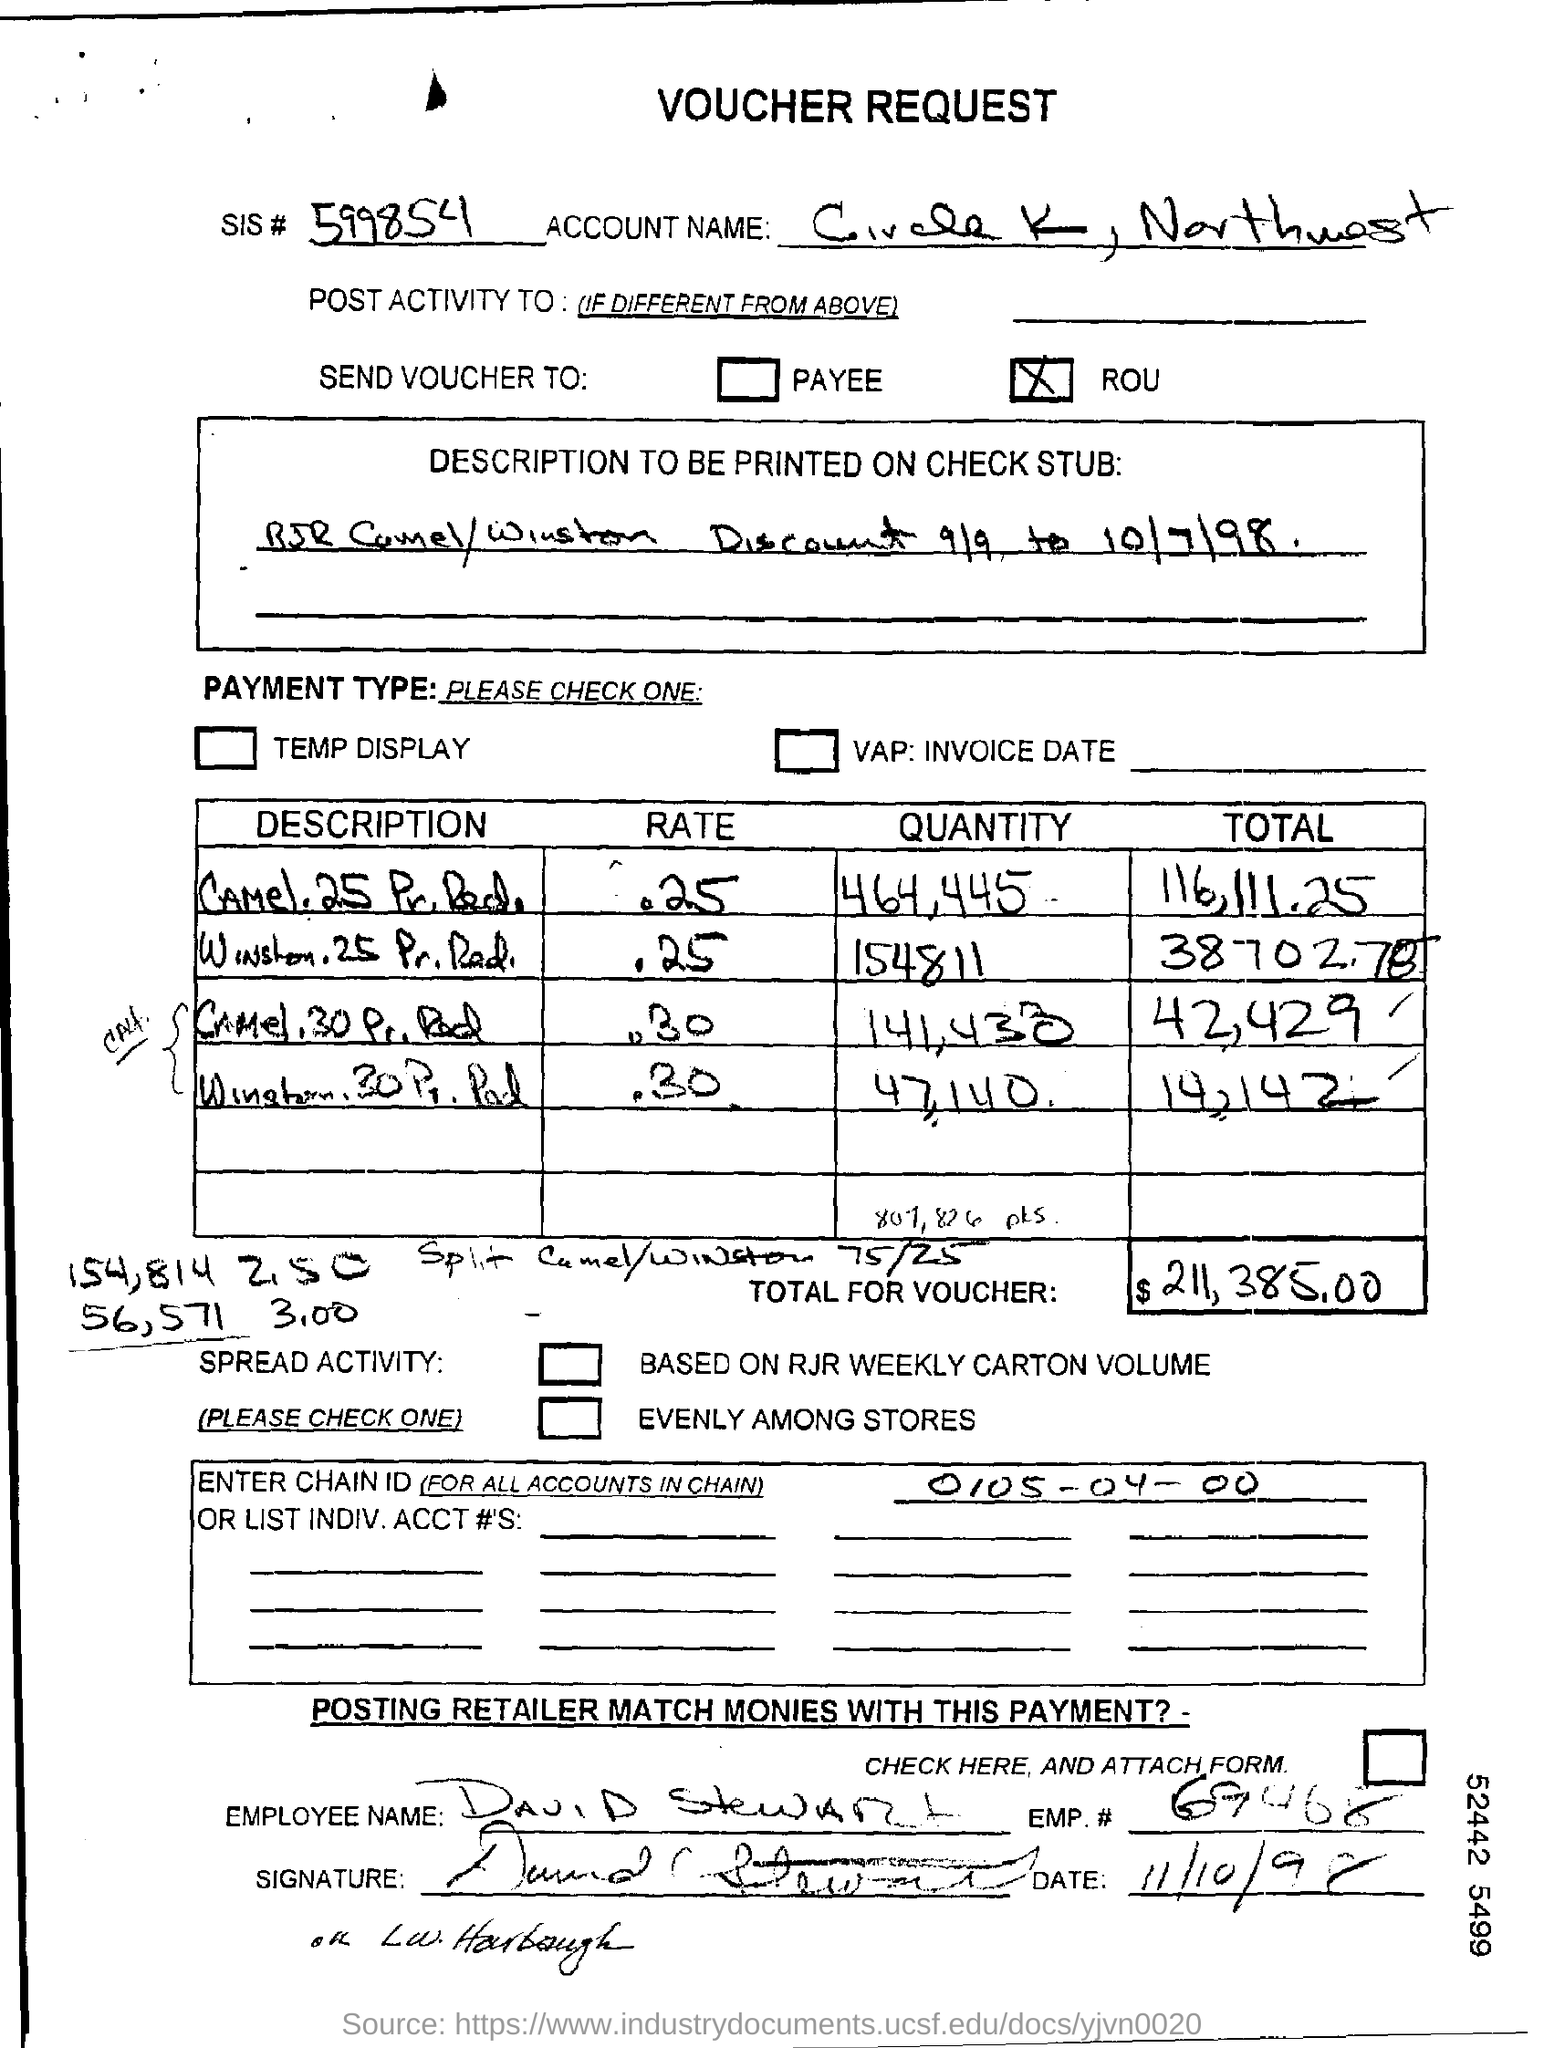What is the sis # given in the voucher request form?
Give a very brief answer. 599854. What is the description to be printed on check stub?
Your response must be concise. RJR Camel/Winston Discount 9/9 to 10/7/98. What is the employee name mentioned in the voucher request form?
Give a very brief answer. David Stewart. What is the Emp. no. of David Stewart?
Your answer should be compact. 69468. What is the total amount mentioned in the voucher?
Keep it short and to the point. 211,385.00. What is the chain ID given in the voucher request form?
Your answer should be very brief. 0105-04-00. 